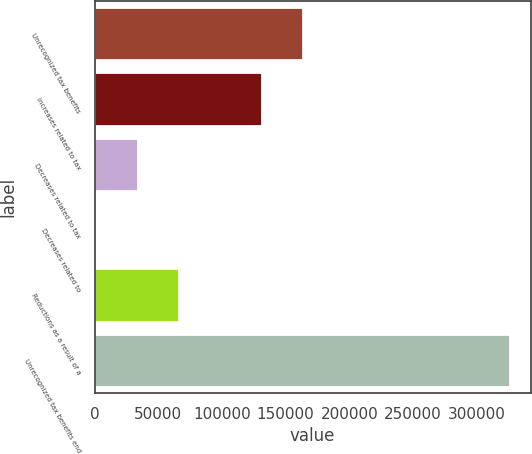Convert chart. <chart><loc_0><loc_0><loc_500><loc_500><bar_chart><fcel>Unrecognized tax benefits<fcel>Increases related to tax<fcel>Decreases related to tax<fcel>Decreases related to<fcel>Reductions as a result of a<fcel>Unrecognized tax benefits end<nl><fcel>163738<fcel>131269<fcel>33858.9<fcel>1389<fcel>66328.8<fcel>326088<nl></chart> 